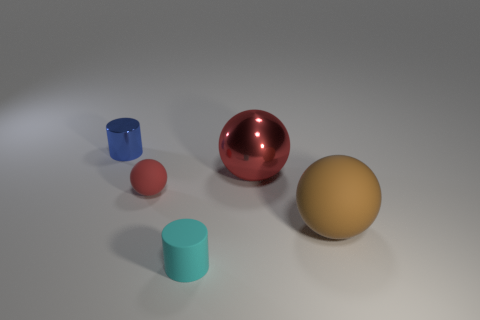Add 1 cylinders. How many objects exist? 6 Subtract all cylinders. How many objects are left? 3 Add 4 brown matte things. How many brown matte things exist? 5 Subtract 1 cyan cylinders. How many objects are left? 4 Subtract all tiny blue objects. Subtract all tiny blue metal cylinders. How many objects are left? 3 Add 2 small cylinders. How many small cylinders are left? 4 